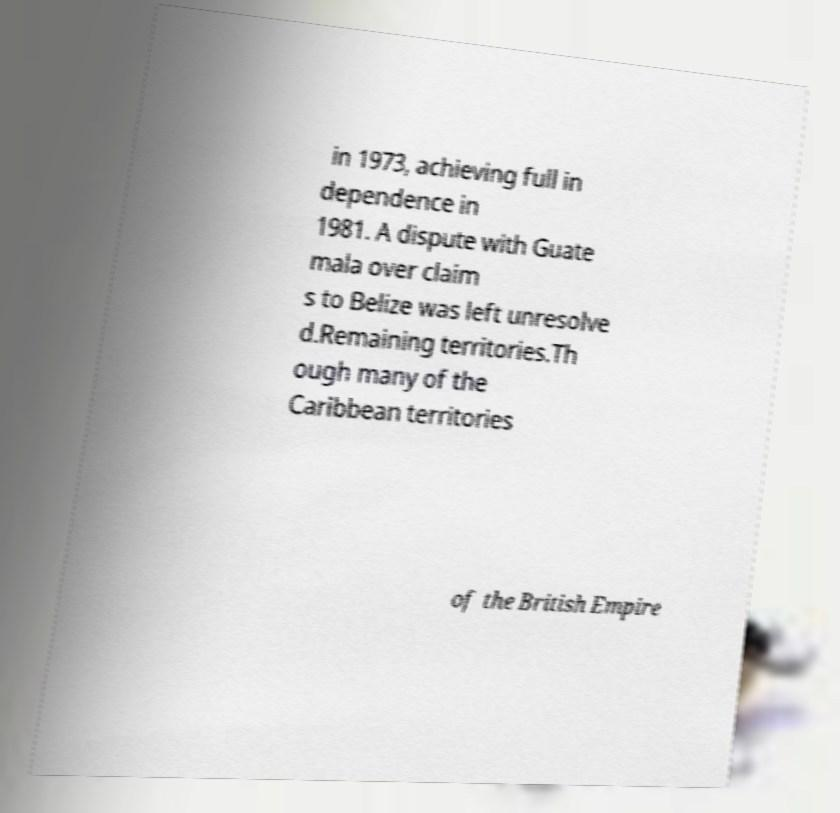For documentation purposes, I need the text within this image transcribed. Could you provide that? in 1973, achieving full in dependence in 1981. A dispute with Guate mala over claim s to Belize was left unresolve d.Remaining territories.Th ough many of the Caribbean territories of the British Empire 